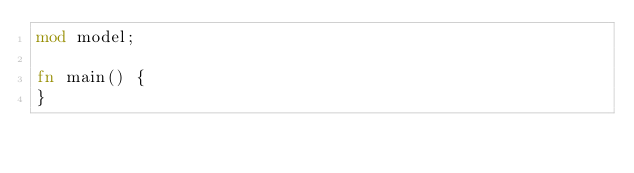<code> <loc_0><loc_0><loc_500><loc_500><_Rust_>mod model;

fn main() {
}
</code> 